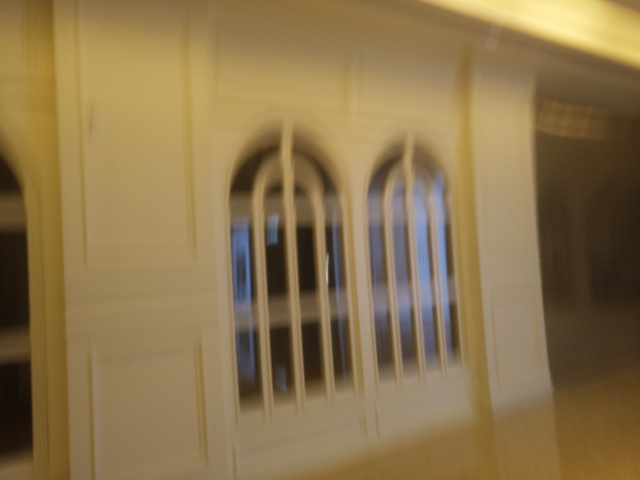Can you suggest how to take a better picture of this scene? To take a clearer picture of this scene, ensure the camera is stable, perhaps using a tripod. Also, adjust the focus correctly and choose a higher resolution. Additionally, consider the lighting conditions; natural light can enhance the photo's quality. 